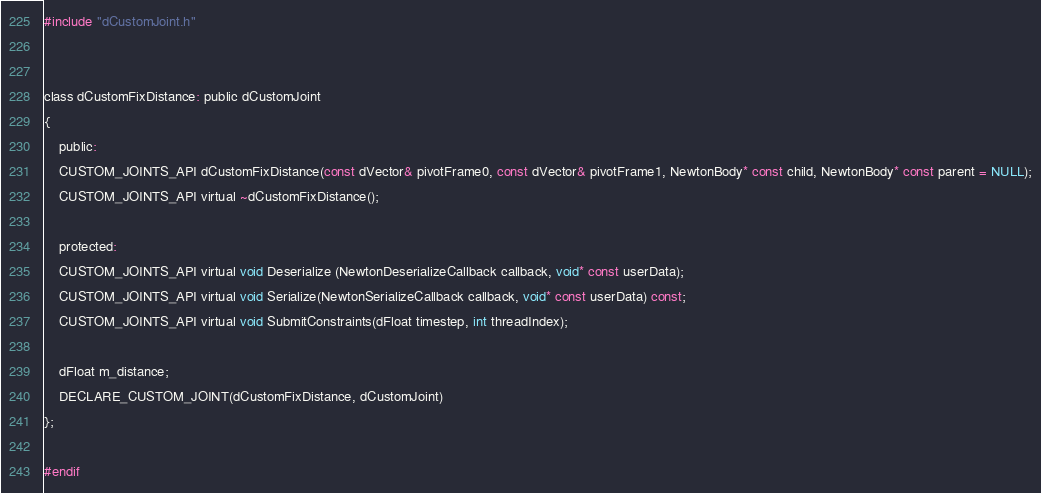Convert code to text. <code><loc_0><loc_0><loc_500><loc_500><_C_>
#include "dCustomJoint.h"


class dCustomFixDistance: public dCustomJoint  
{
	public:
	CUSTOM_JOINTS_API dCustomFixDistance(const dVector& pivotFrame0, const dVector& pivotFrame1, NewtonBody* const child, NewtonBody* const parent = NULL);
	CUSTOM_JOINTS_API virtual ~dCustomFixDistance();

	protected:
	CUSTOM_JOINTS_API virtual void Deserialize (NewtonDeserializeCallback callback, void* const userData);
	CUSTOM_JOINTS_API virtual void Serialize(NewtonSerializeCallback callback, void* const userData) const;
	CUSTOM_JOINTS_API virtual void SubmitConstraints(dFloat timestep, int threadIndex);

	dFloat m_distance;
	DECLARE_CUSTOM_JOINT(dCustomFixDistance, dCustomJoint)
};

#endif 

</code> 